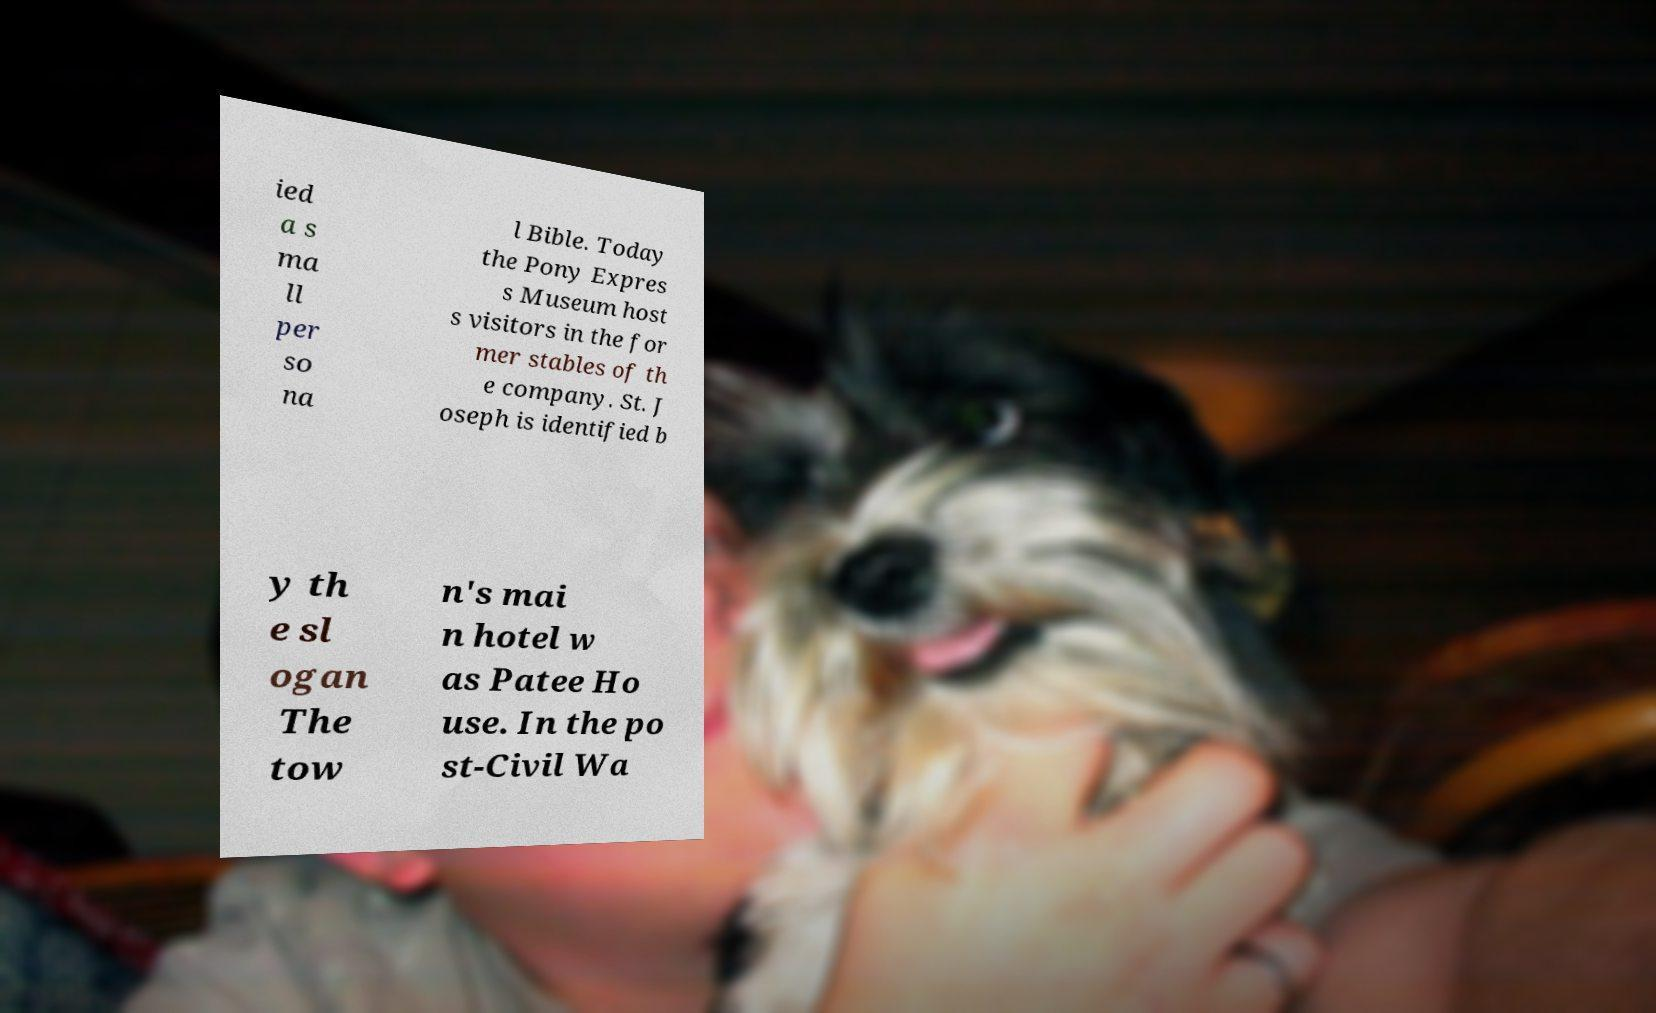What messages or text are displayed in this image? I need them in a readable, typed format. ied a s ma ll per so na l Bible. Today the Pony Expres s Museum host s visitors in the for mer stables of th e company. St. J oseph is identified b y th e sl ogan The tow n's mai n hotel w as Patee Ho use. In the po st-Civil Wa 